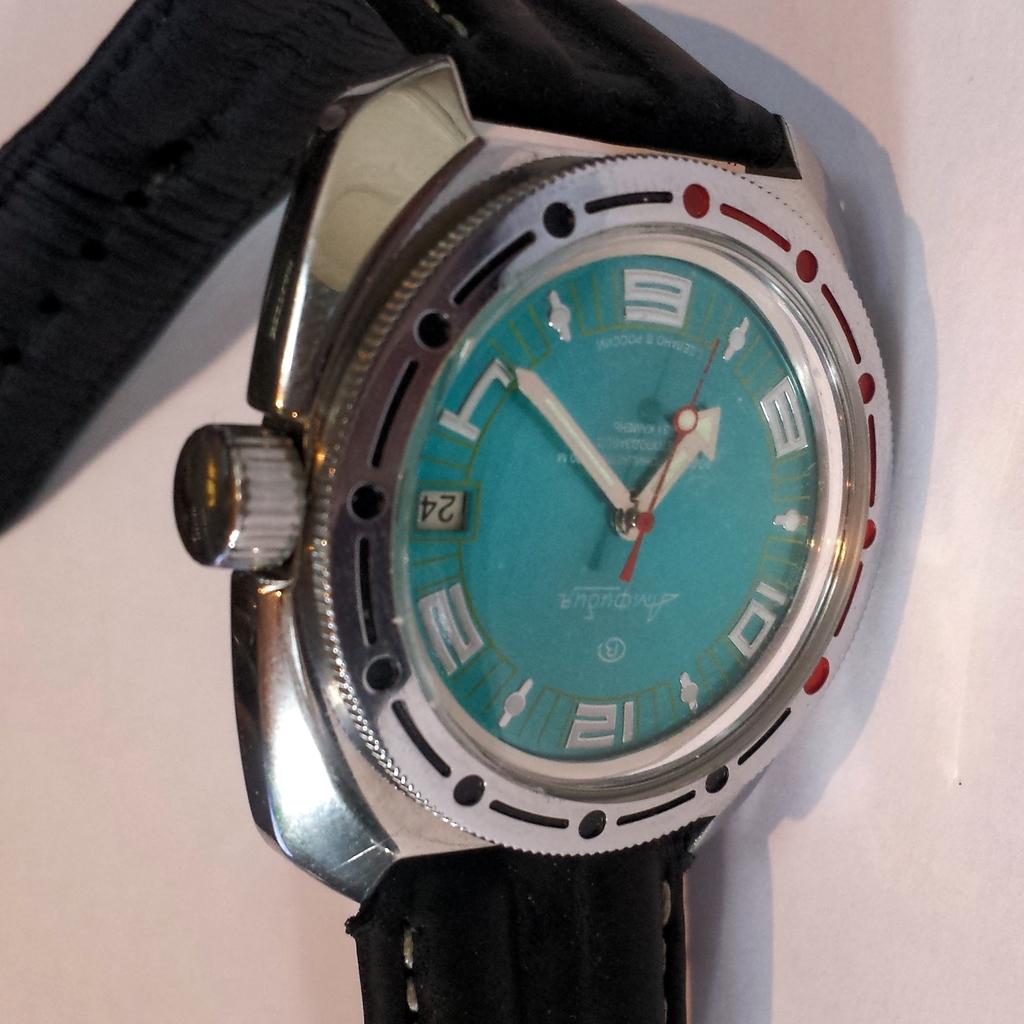What day number is on the watch?
Provide a succinct answer. 24. What time is shown on the watch?
Offer a very short reply. 7:23. 